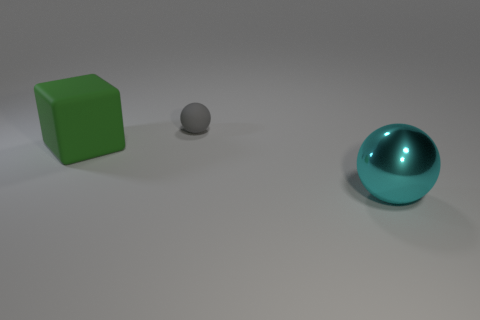Is there any other thing that has the same material as the gray ball?
Make the answer very short. Yes. There is a cyan object that is in front of the rubber ball; is it the same size as the gray ball?
Provide a short and direct response. No. Is the cube the same color as the rubber sphere?
Offer a very short reply. No. How many red spheres are there?
Provide a succinct answer. 0. How many balls are either gray rubber things or large green rubber things?
Provide a succinct answer. 1. What number of things are behind the large object left of the large metal object?
Ensure brevity in your answer.  1. Do the big green thing and the small gray ball have the same material?
Your answer should be compact. Yes. Are there any small objects that have the same material as the big block?
Provide a succinct answer. Yes. What is the color of the object that is on the right side of the ball behind the large object left of the large shiny thing?
Make the answer very short. Cyan. What number of yellow objects are either large matte things or spheres?
Your response must be concise. 0. 